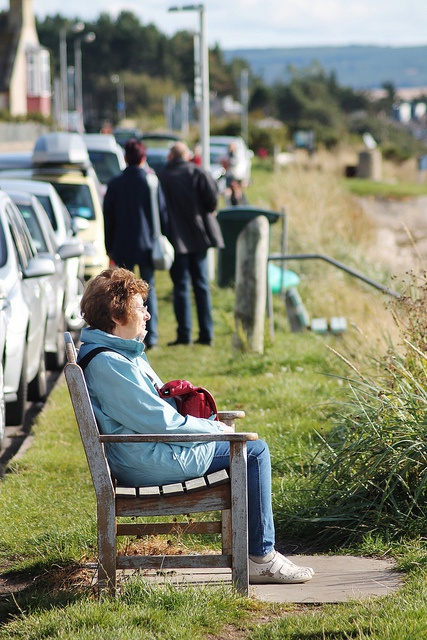Describe the objects in this image and their specific colors. I can see bench in white, gray, black, maroon, and darkgreen tones, people in white, gray, and black tones, car in white, lightgray, darkgray, black, and gray tones, people in white, black, gray, darkgray, and lightgray tones, and people in white, black, gray, and darkgray tones in this image. 